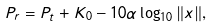Convert formula to latex. <formula><loc_0><loc_0><loc_500><loc_500>P _ { r } = P _ { t } + K _ { 0 } - 1 0 \alpha \log _ { 1 0 } \| x \| ,</formula> 